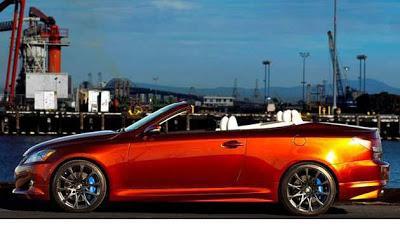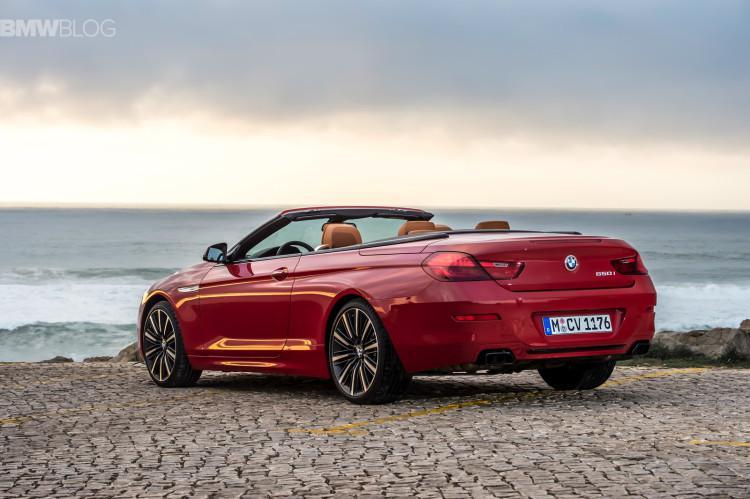The first image is the image on the left, the second image is the image on the right. Examine the images to the left and right. Is the description "The right image has a convertible with the ocean visible behind it" accurate? Answer yes or no. Yes. The first image is the image on the left, the second image is the image on the right. Given the left and right images, does the statement "Both cars are red." hold true? Answer yes or no. Yes. 